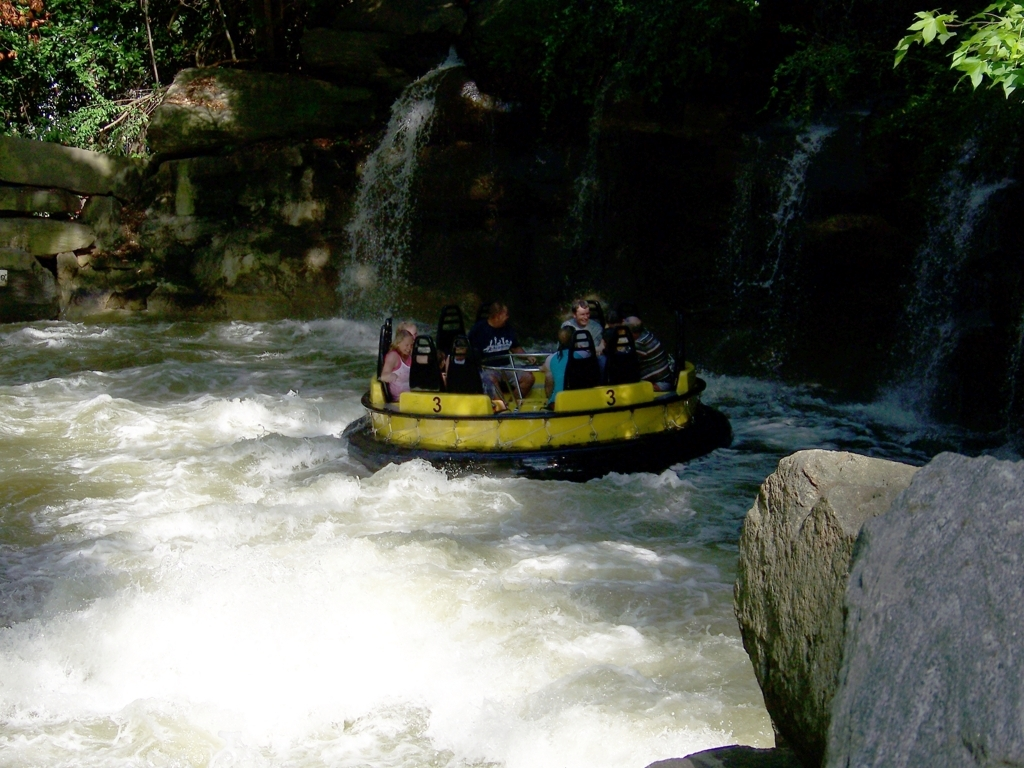Is the brightness dark? While the surroundings appear dimly lit, with shadows cast upon the rocks and foliage, the overall brightness of the photo is not dark. The swift water and the raft are well-illuminated, suggesting a presence of light, possibly natural daylight, which brightens significant portions of the scene. 